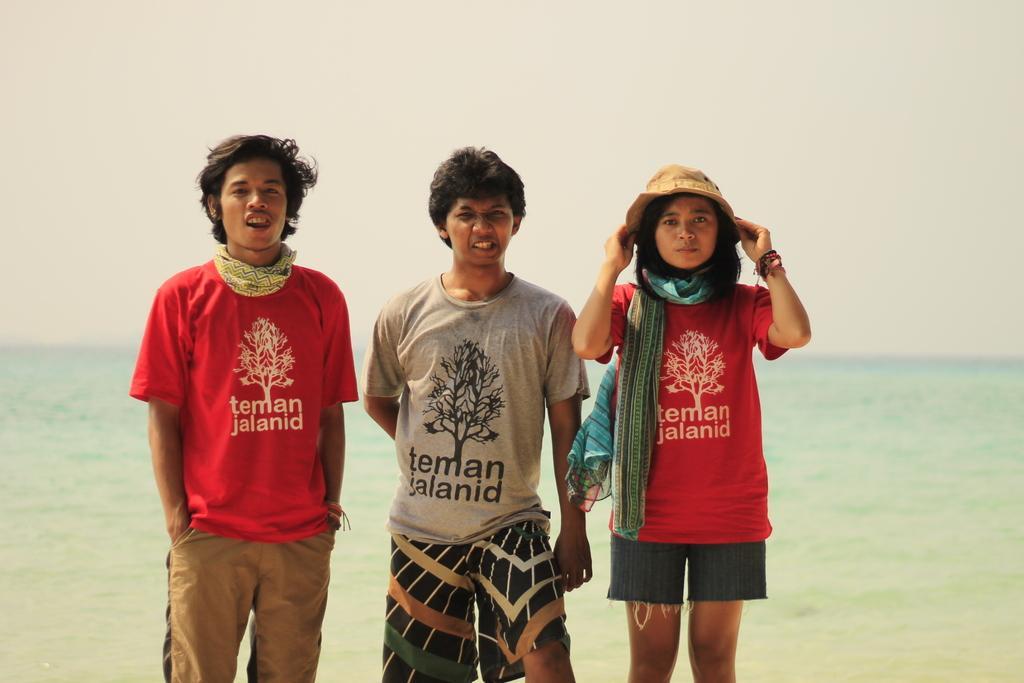How would you summarize this image in a sentence or two? In the image there are three people standing in the foreground and behind them there is a beach. 